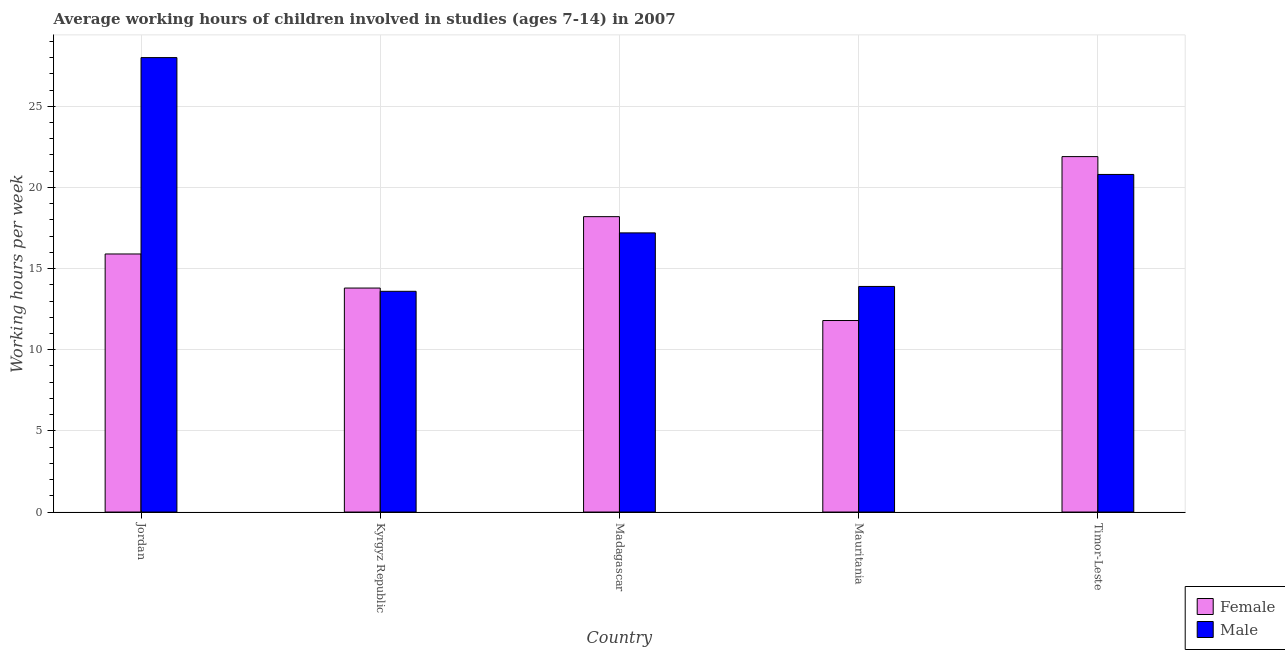How many groups of bars are there?
Ensure brevity in your answer.  5. What is the label of the 2nd group of bars from the left?
Keep it short and to the point. Kyrgyz Republic. In how many cases, is the number of bars for a given country not equal to the number of legend labels?
Your answer should be very brief. 0. Across all countries, what is the maximum average working hour of female children?
Offer a very short reply. 21.9. Across all countries, what is the minimum average working hour of male children?
Ensure brevity in your answer.  13.6. In which country was the average working hour of male children maximum?
Make the answer very short. Jordan. In which country was the average working hour of male children minimum?
Make the answer very short. Kyrgyz Republic. What is the total average working hour of female children in the graph?
Provide a short and direct response. 81.6. What is the difference between the average working hour of male children in Mauritania and the average working hour of female children in Kyrgyz Republic?
Give a very brief answer. 0.1. What is the average average working hour of male children per country?
Provide a succinct answer. 18.7. What is the difference between the average working hour of male children and average working hour of female children in Timor-Leste?
Offer a very short reply. -1.1. What is the ratio of the average working hour of female children in Jordan to that in Timor-Leste?
Your answer should be compact. 0.73. Is the average working hour of male children in Madagascar less than that in Timor-Leste?
Offer a terse response. Yes. Is the difference between the average working hour of female children in Jordan and Timor-Leste greater than the difference between the average working hour of male children in Jordan and Timor-Leste?
Provide a succinct answer. No. What is the difference between the highest and the second highest average working hour of female children?
Offer a terse response. 3.7. What is the difference between the highest and the lowest average working hour of female children?
Offer a terse response. 10.1. In how many countries, is the average working hour of male children greater than the average average working hour of male children taken over all countries?
Your response must be concise. 2. Is the sum of the average working hour of female children in Madagascar and Mauritania greater than the maximum average working hour of male children across all countries?
Your response must be concise. Yes. What does the 1st bar from the right in Mauritania represents?
Provide a short and direct response. Male. What is the difference between two consecutive major ticks on the Y-axis?
Offer a terse response. 5. Are the values on the major ticks of Y-axis written in scientific E-notation?
Your answer should be compact. No. Does the graph contain grids?
Make the answer very short. Yes. How many legend labels are there?
Provide a short and direct response. 2. How are the legend labels stacked?
Provide a succinct answer. Vertical. What is the title of the graph?
Offer a terse response. Average working hours of children involved in studies (ages 7-14) in 2007. What is the label or title of the Y-axis?
Make the answer very short. Working hours per week. What is the Working hours per week in Female in Jordan?
Your answer should be very brief. 15.9. What is the Working hours per week of Female in Kyrgyz Republic?
Your response must be concise. 13.8. What is the Working hours per week in Male in Kyrgyz Republic?
Provide a short and direct response. 13.6. What is the Working hours per week of Female in Mauritania?
Make the answer very short. 11.8. What is the Working hours per week in Male in Mauritania?
Offer a very short reply. 13.9. What is the Working hours per week of Female in Timor-Leste?
Provide a short and direct response. 21.9. What is the Working hours per week of Male in Timor-Leste?
Keep it short and to the point. 20.8. Across all countries, what is the maximum Working hours per week of Female?
Give a very brief answer. 21.9. Across all countries, what is the maximum Working hours per week of Male?
Make the answer very short. 28. Across all countries, what is the minimum Working hours per week of Female?
Your answer should be compact. 11.8. Across all countries, what is the minimum Working hours per week of Male?
Ensure brevity in your answer.  13.6. What is the total Working hours per week in Female in the graph?
Provide a short and direct response. 81.6. What is the total Working hours per week in Male in the graph?
Your response must be concise. 93.5. What is the difference between the Working hours per week of Female in Jordan and that in Timor-Leste?
Your answer should be compact. -6. What is the difference between the Working hours per week of Female in Kyrgyz Republic and that in Mauritania?
Keep it short and to the point. 2. What is the difference between the Working hours per week of Female in Kyrgyz Republic and that in Timor-Leste?
Give a very brief answer. -8.1. What is the difference between the Working hours per week of Female in Madagascar and that in Mauritania?
Provide a short and direct response. 6.4. What is the difference between the Working hours per week in Male in Madagascar and that in Mauritania?
Your answer should be compact. 3.3. What is the difference between the Working hours per week in Male in Mauritania and that in Timor-Leste?
Your answer should be compact. -6.9. What is the difference between the Working hours per week in Female in Jordan and the Working hours per week in Male in Kyrgyz Republic?
Make the answer very short. 2.3. What is the difference between the Working hours per week of Female in Jordan and the Working hours per week of Male in Madagascar?
Provide a short and direct response. -1.3. What is the difference between the Working hours per week in Female in Kyrgyz Republic and the Working hours per week in Male in Madagascar?
Offer a very short reply. -3.4. What is the difference between the Working hours per week of Female in Kyrgyz Republic and the Working hours per week of Male in Mauritania?
Your answer should be very brief. -0.1. What is the difference between the Working hours per week in Female in Madagascar and the Working hours per week in Male in Timor-Leste?
Provide a short and direct response. -2.6. What is the average Working hours per week of Female per country?
Provide a succinct answer. 16.32. What is the average Working hours per week of Male per country?
Make the answer very short. 18.7. What is the difference between the Working hours per week of Female and Working hours per week of Male in Kyrgyz Republic?
Your answer should be compact. 0.2. What is the difference between the Working hours per week of Female and Working hours per week of Male in Timor-Leste?
Keep it short and to the point. 1.1. What is the ratio of the Working hours per week of Female in Jordan to that in Kyrgyz Republic?
Give a very brief answer. 1.15. What is the ratio of the Working hours per week of Male in Jordan to that in Kyrgyz Republic?
Your answer should be compact. 2.06. What is the ratio of the Working hours per week in Female in Jordan to that in Madagascar?
Your answer should be compact. 0.87. What is the ratio of the Working hours per week in Male in Jordan to that in Madagascar?
Make the answer very short. 1.63. What is the ratio of the Working hours per week of Female in Jordan to that in Mauritania?
Give a very brief answer. 1.35. What is the ratio of the Working hours per week in Male in Jordan to that in Mauritania?
Your answer should be very brief. 2.01. What is the ratio of the Working hours per week in Female in Jordan to that in Timor-Leste?
Give a very brief answer. 0.73. What is the ratio of the Working hours per week in Male in Jordan to that in Timor-Leste?
Provide a short and direct response. 1.35. What is the ratio of the Working hours per week of Female in Kyrgyz Republic to that in Madagascar?
Offer a very short reply. 0.76. What is the ratio of the Working hours per week in Male in Kyrgyz Republic to that in Madagascar?
Keep it short and to the point. 0.79. What is the ratio of the Working hours per week in Female in Kyrgyz Republic to that in Mauritania?
Your response must be concise. 1.17. What is the ratio of the Working hours per week of Male in Kyrgyz Republic to that in Mauritania?
Give a very brief answer. 0.98. What is the ratio of the Working hours per week of Female in Kyrgyz Republic to that in Timor-Leste?
Offer a terse response. 0.63. What is the ratio of the Working hours per week in Male in Kyrgyz Republic to that in Timor-Leste?
Offer a terse response. 0.65. What is the ratio of the Working hours per week of Female in Madagascar to that in Mauritania?
Provide a succinct answer. 1.54. What is the ratio of the Working hours per week in Male in Madagascar to that in Mauritania?
Give a very brief answer. 1.24. What is the ratio of the Working hours per week in Female in Madagascar to that in Timor-Leste?
Your answer should be compact. 0.83. What is the ratio of the Working hours per week in Male in Madagascar to that in Timor-Leste?
Keep it short and to the point. 0.83. What is the ratio of the Working hours per week of Female in Mauritania to that in Timor-Leste?
Make the answer very short. 0.54. What is the ratio of the Working hours per week of Male in Mauritania to that in Timor-Leste?
Your answer should be compact. 0.67. What is the difference between the highest and the second highest Working hours per week of Female?
Ensure brevity in your answer.  3.7. What is the difference between the highest and the lowest Working hours per week in Female?
Provide a short and direct response. 10.1. 